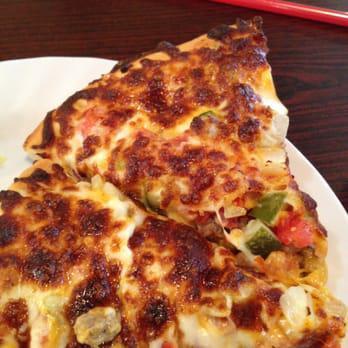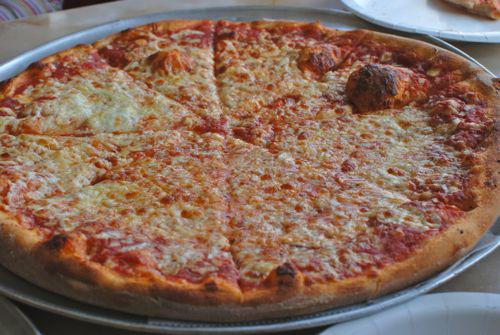The first image is the image on the left, the second image is the image on the right. Analyze the images presented: Is the assertion "In at least one image there is a pepperoni pizza with a serving utenical underneath at least one slice." valid? Answer yes or no. No. 